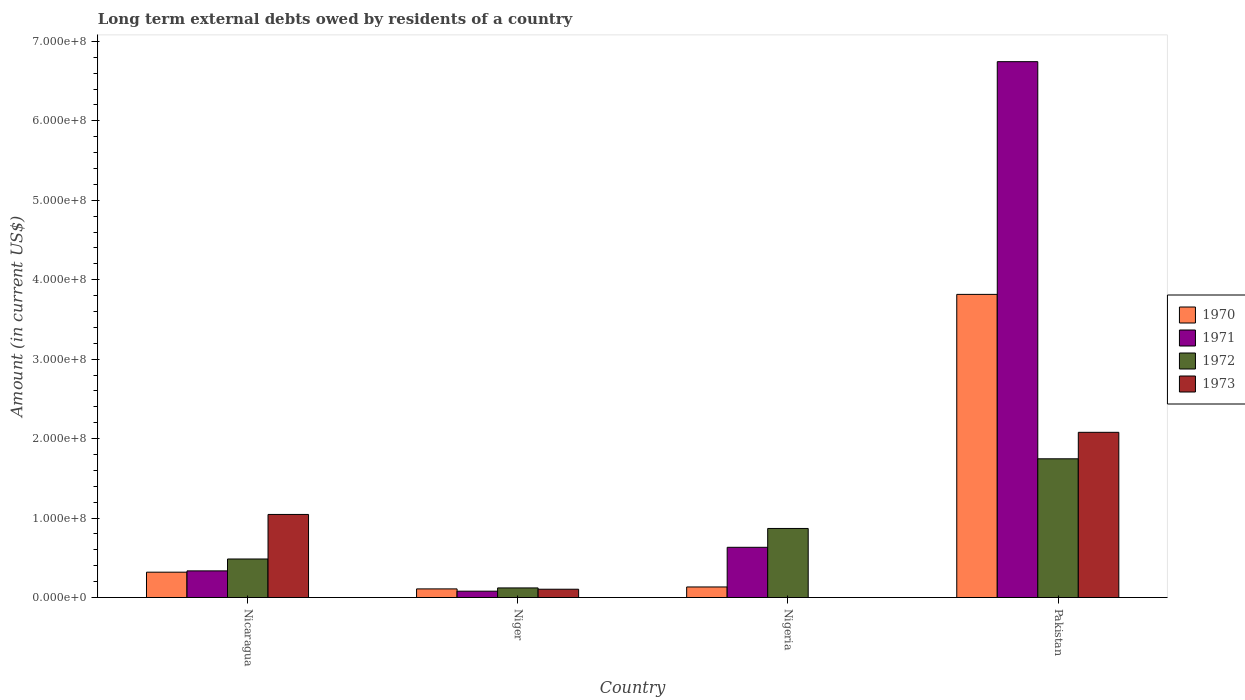How many bars are there on the 3rd tick from the left?
Provide a short and direct response. 3. What is the label of the 3rd group of bars from the left?
Provide a short and direct response. Nigeria. In how many cases, is the number of bars for a given country not equal to the number of legend labels?
Offer a terse response. 1. What is the amount of long-term external debts owed by residents in 1972 in Nigeria?
Make the answer very short. 8.69e+07. Across all countries, what is the maximum amount of long-term external debts owed by residents in 1973?
Your response must be concise. 2.08e+08. Across all countries, what is the minimum amount of long-term external debts owed by residents in 1971?
Make the answer very short. 8.00e+06. What is the total amount of long-term external debts owed by residents in 1970 in the graph?
Your answer should be very brief. 4.38e+08. What is the difference between the amount of long-term external debts owed by residents in 1970 in Nicaragua and that in Niger?
Keep it short and to the point. 2.10e+07. What is the difference between the amount of long-term external debts owed by residents in 1973 in Nicaragua and the amount of long-term external debts owed by residents in 1972 in Nigeria?
Offer a terse response. 1.77e+07. What is the average amount of long-term external debts owed by residents in 1971 per country?
Make the answer very short. 1.95e+08. What is the difference between the amount of long-term external debts owed by residents of/in 1971 and amount of long-term external debts owed by residents of/in 1973 in Pakistan?
Your response must be concise. 4.67e+08. In how many countries, is the amount of long-term external debts owed by residents in 1971 greater than 20000000 US$?
Make the answer very short. 3. What is the ratio of the amount of long-term external debts owed by residents in 1972 in Niger to that in Pakistan?
Make the answer very short. 0.07. Is the difference between the amount of long-term external debts owed by residents in 1971 in Nicaragua and Niger greater than the difference between the amount of long-term external debts owed by residents in 1973 in Nicaragua and Niger?
Your answer should be compact. No. What is the difference between the highest and the second highest amount of long-term external debts owed by residents in 1973?
Make the answer very short. 1.97e+08. What is the difference between the highest and the lowest amount of long-term external debts owed by residents in 1973?
Provide a short and direct response. 2.08e+08. Is the sum of the amount of long-term external debts owed by residents in 1971 in Nigeria and Pakistan greater than the maximum amount of long-term external debts owed by residents in 1970 across all countries?
Your response must be concise. Yes. Is it the case that in every country, the sum of the amount of long-term external debts owed by residents in 1971 and amount of long-term external debts owed by residents in 1973 is greater than the sum of amount of long-term external debts owed by residents in 1970 and amount of long-term external debts owed by residents in 1972?
Provide a succinct answer. No. Are all the bars in the graph horizontal?
Offer a very short reply. No. How many countries are there in the graph?
Offer a very short reply. 4. Are the values on the major ticks of Y-axis written in scientific E-notation?
Offer a terse response. Yes. Does the graph contain grids?
Ensure brevity in your answer.  No. Where does the legend appear in the graph?
Your answer should be compact. Center right. How many legend labels are there?
Your response must be concise. 4. What is the title of the graph?
Your answer should be compact. Long term external debts owed by residents of a country. Does "1987" appear as one of the legend labels in the graph?
Your response must be concise. No. What is the label or title of the X-axis?
Your answer should be very brief. Country. What is the label or title of the Y-axis?
Ensure brevity in your answer.  Amount (in current US$). What is the Amount (in current US$) in 1970 in Nicaragua?
Offer a terse response. 3.19e+07. What is the Amount (in current US$) of 1971 in Nicaragua?
Make the answer very short. 3.35e+07. What is the Amount (in current US$) of 1972 in Nicaragua?
Your response must be concise. 4.85e+07. What is the Amount (in current US$) of 1973 in Nicaragua?
Provide a succinct answer. 1.05e+08. What is the Amount (in current US$) of 1970 in Niger?
Offer a terse response. 1.09e+07. What is the Amount (in current US$) of 1971 in Niger?
Keep it short and to the point. 8.00e+06. What is the Amount (in current US$) in 1972 in Niger?
Make the answer very short. 1.21e+07. What is the Amount (in current US$) in 1973 in Niger?
Provide a short and direct response. 1.04e+07. What is the Amount (in current US$) in 1970 in Nigeria?
Provide a short and direct response. 1.33e+07. What is the Amount (in current US$) in 1971 in Nigeria?
Make the answer very short. 6.32e+07. What is the Amount (in current US$) of 1972 in Nigeria?
Keep it short and to the point. 8.69e+07. What is the Amount (in current US$) in 1973 in Nigeria?
Give a very brief answer. 0. What is the Amount (in current US$) of 1970 in Pakistan?
Make the answer very short. 3.82e+08. What is the Amount (in current US$) in 1971 in Pakistan?
Make the answer very short. 6.74e+08. What is the Amount (in current US$) in 1972 in Pakistan?
Your answer should be very brief. 1.75e+08. What is the Amount (in current US$) in 1973 in Pakistan?
Your response must be concise. 2.08e+08. Across all countries, what is the maximum Amount (in current US$) of 1970?
Your answer should be compact. 3.82e+08. Across all countries, what is the maximum Amount (in current US$) in 1971?
Provide a short and direct response. 6.74e+08. Across all countries, what is the maximum Amount (in current US$) of 1972?
Your answer should be compact. 1.75e+08. Across all countries, what is the maximum Amount (in current US$) in 1973?
Your answer should be very brief. 2.08e+08. Across all countries, what is the minimum Amount (in current US$) in 1970?
Provide a short and direct response. 1.09e+07. Across all countries, what is the minimum Amount (in current US$) in 1971?
Offer a very short reply. 8.00e+06. Across all countries, what is the minimum Amount (in current US$) in 1972?
Make the answer very short. 1.21e+07. Across all countries, what is the minimum Amount (in current US$) in 1973?
Keep it short and to the point. 0. What is the total Amount (in current US$) of 1970 in the graph?
Offer a terse response. 4.38e+08. What is the total Amount (in current US$) in 1971 in the graph?
Ensure brevity in your answer.  7.79e+08. What is the total Amount (in current US$) of 1972 in the graph?
Offer a terse response. 3.22e+08. What is the total Amount (in current US$) in 1973 in the graph?
Your answer should be compact. 3.23e+08. What is the difference between the Amount (in current US$) of 1970 in Nicaragua and that in Niger?
Ensure brevity in your answer.  2.10e+07. What is the difference between the Amount (in current US$) of 1971 in Nicaragua and that in Niger?
Offer a terse response. 2.55e+07. What is the difference between the Amount (in current US$) of 1972 in Nicaragua and that in Niger?
Ensure brevity in your answer.  3.64e+07. What is the difference between the Amount (in current US$) of 1973 in Nicaragua and that in Niger?
Make the answer very short. 9.41e+07. What is the difference between the Amount (in current US$) in 1970 in Nicaragua and that in Nigeria?
Make the answer very short. 1.86e+07. What is the difference between the Amount (in current US$) in 1971 in Nicaragua and that in Nigeria?
Provide a succinct answer. -2.97e+07. What is the difference between the Amount (in current US$) of 1972 in Nicaragua and that in Nigeria?
Make the answer very short. -3.84e+07. What is the difference between the Amount (in current US$) of 1970 in Nicaragua and that in Pakistan?
Your answer should be compact. -3.50e+08. What is the difference between the Amount (in current US$) in 1971 in Nicaragua and that in Pakistan?
Your response must be concise. -6.41e+08. What is the difference between the Amount (in current US$) of 1972 in Nicaragua and that in Pakistan?
Give a very brief answer. -1.26e+08. What is the difference between the Amount (in current US$) of 1973 in Nicaragua and that in Pakistan?
Offer a terse response. -1.03e+08. What is the difference between the Amount (in current US$) in 1970 in Niger and that in Nigeria?
Your response must be concise. -2.44e+06. What is the difference between the Amount (in current US$) in 1971 in Niger and that in Nigeria?
Offer a terse response. -5.52e+07. What is the difference between the Amount (in current US$) of 1972 in Niger and that in Nigeria?
Ensure brevity in your answer.  -7.48e+07. What is the difference between the Amount (in current US$) of 1970 in Niger and that in Pakistan?
Offer a very short reply. -3.71e+08. What is the difference between the Amount (in current US$) of 1971 in Niger and that in Pakistan?
Offer a very short reply. -6.66e+08. What is the difference between the Amount (in current US$) of 1972 in Niger and that in Pakistan?
Keep it short and to the point. -1.63e+08. What is the difference between the Amount (in current US$) in 1973 in Niger and that in Pakistan?
Offer a very short reply. -1.97e+08. What is the difference between the Amount (in current US$) of 1970 in Nigeria and that in Pakistan?
Offer a terse response. -3.68e+08. What is the difference between the Amount (in current US$) in 1971 in Nigeria and that in Pakistan?
Offer a very short reply. -6.11e+08. What is the difference between the Amount (in current US$) of 1972 in Nigeria and that in Pakistan?
Provide a succinct answer. -8.77e+07. What is the difference between the Amount (in current US$) of 1970 in Nicaragua and the Amount (in current US$) of 1971 in Niger?
Ensure brevity in your answer.  2.39e+07. What is the difference between the Amount (in current US$) in 1970 in Nicaragua and the Amount (in current US$) in 1972 in Niger?
Keep it short and to the point. 1.98e+07. What is the difference between the Amount (in current US$) in 1970 in Nicaragua and the Amount (in current US$) in 1973 in Niger?
Ensure brevity in your answer.  2.15e+07. What is the difference between the Amount (in current US$) in 1971 in Nicaragua and the Amount (in current US$) in 1972 in Niger?
Your response must be concise. 2.14e+07. What is the difference between the Amount (in current US$) in 1971 in Nicaragua and the Amount (in current US$) in 1973 in Niger?
Keep it short and to the point. 2.31e+07. What is the difference between the Amount (in current US$) in 1972 in Nicaragua and the Amount (in current US$) in 1973 in Niger?
Your answer should be very brief. 3.81e+07. What is the difference between the Amount (in current US$) in 1970 in Nicaragua and the Amount (in current US$) in 1971 in Nigeria?
Give a very brief answer. -3.13e+07. What is the difference between the Amount (in current US$) of 1970 in Nicaragua and the Amount (in current US$) of 1972 in Nigeria?
Your answer should be very brief. -5.50e+07. What is the difference between the Amount (in current US$) of 1971 in Nicaragua and the Amount (in current US$) of 1972 in Nigeria?
Give a very brief answer. -5.34e+07. What is the difference between the Amount (in current US$) in 1970 in Nicaragua and the Amount (in current US$) in 1971 in Pakistan?
Your response must be concise. -6.43e+08. What is the difference between the Amount (in current US$) in 1970 in Nicaragua and the Amount (in current US$) in 1972 in Pakistan?
Keep it short and to the point. -1.43e+08. What is the difference between the Amount (in current US$) in 1970 in Nicaragua and the Amount (in current US$) in 1973 in Pakistan?
Provide a short and direct response. -1.76e+08. What is the difference between the Amount (in current US$) in 1971 in Nicaragua and the Amount (in current US$) in 1972 in Pakistan?
Provide a short and direct response. -1.41e+08. What is the difference between the Amount (in current US$) in 1971 in Nicaragua and the Amount (in current US$) in 1973 in Pakistan?
Provide a succinct answer. -1.74e+08. What is the difference between the Amount (in current US$) of 1972 in Nicaragua and the Amount (in current US$) of 1973 in Pakistan?
Your response must be concise. -1.59e+08. What is the difference between the Amount (in current US$) in 1970 in Niger and the Amount (in current US$) in 1971 in Nigeria?
Make the answer very short. -5.24e+07. What is the difference between the Amount (in current US$) in 1970 in Niger and the Amount (in current US$) in 1972 in Nigeria?
Offer a very short reply. -7.61e+07. What is the difference between the Amount (in current US$) of 1971 in Niger and the Amount (in current US$) of 1972 in Nigeria?
Offer a very short reply. -7.89e+07. What is the difference between the Amount (in current US$) of 1970 in Niger and the Amount (in current US$) of 1971 in Pakistan?
Your answer should be very brief. -6.64e+08. What is the difference between the Amount (in current US$) in 1970 in Niger and the Amount (in current US$) in 1972 in Pakistan?
Offer a terse response. -1.64e+08. What is the difference between the Amount (in current US$) of 1970 in Niger and the Amount (in current US$) of 1973 in Pakistan?
Keep it short and to the point. -1.97e+08. What is the difference between the Amount (in current US$) in 1971 in Niger and the Amount (in current US$) in 1972 in Pakistan?
Offer a terse response. -1.67e+08. What is the difference between the Amount (in current US$) in 1971 in Niger and the Amount (in current US$) in 1973 in Pakistan?
Your answer should be compact. -2.00e+08. What is the difference between the Amount (in current US$) of 1972 in Niger and the Amount (in current US$) of 1973 in Pakistan?
Make the answer very short. -1.96e+08. What is the difference between the Amount (in current US$) in 1970 in Nigeria and the Amount (in current US$) in 1971 in Pakistan?
Your answer should be compact. -6.61e+08. What is the difference between the Amount (in current US$) in 1970 in Nigeria and the Amount (in current US$) in 1972 in Pakistan?
Give a very brief answer. -1.61e+08. What is the difference between the Amount (in current US$) of 1970 in Nigeria and the Amount (in current US$) of 1973 in Pakistan?
Provide a short and direct response. -1.95e+08. What is the difference between the Amount (in current US$) of 1971 in Nigeria and the Amount (in current US$) of 1972 in Pakistan?
Give a very brief answer. -1.11e+08. What is the difference between the Amount (in current US$) of 1971 in Nigeria and the Amount (in current US$) of 1973 in Pakistan?
Offer a terse response. -1.45e+08. What is the difference between the Amount (in current US$) in 1972 in Nigeria and the Amount (in current US$) in 1973 in Pakistan?
Keep it short and to the point. -1.21e+08. What is the average Amount (in current US$) in 1970 per country?
Ensure brevity in your answer.  1.09e+08. What is the average Amount (in current US$) of 1971 per country?
Provide a succinct answer. 1.95e+08. What is the average Amount (in current US$) in 1972 per country?
Offer a terse response. 8.05e+07. What is the average Amount (in current US$) in 1973 per country?
Your answer should be very brief. 8.07e+07. What is the difference between the Amount (in current US$) of 1970 and Amount (in current US$) of 1971 in Nicaragua?
Offer a terse response. -1.63e+06. What is the difference between the Amount (in current US$) in 1970 and Amount (in current US$) in 1972 in Nicaragua?
Keep it short and to the point. -1.66e+07. What is the difference between the Amount (in current US$) of 1970 and Amount (in current US$) of 1973 in Nicaragua?
Your answer should be very brief. -7.27e+07. What is the difference between the Amount (in current US$) in 1971 and Amount (in current US$) in 1972 in Nicaragua?
Provide a succinct answer. -1.50e+07. What is the difference between the Amount (in current US$) in 1971 and Amount (in current US$) in 1973 in Nicaragua?
Offer a very short reply. -7.10e+07. What is the difference between the Amount (in current US$) in 1972 and Amount (in current US$) in 1973 in Nicaragua?
Provide a short and direct response. -5.61e+07. What is the difference between the Amount (in current US$) of 1970 and Amount (in current US$) of 1971 in Niger?
Keep it short and to the point. 2.86e+06. What is the difference between the Amount (in current US$) in 1970 and Amount (in current US$) in 1972 in Niger?
Give a very brief answer. -1.23e+06. What is the difference between the Amount (in current US$) in 1970 and Amount (in current US$) in 1973 in Niger?
Offer a terse response. 4.08e+05. What is the difference between the Amount (in current US$) of 1971 and Amount (in current US$) of 1972 in Niger?
Offer a very short reply. -4.09e+06. What is the difference between the Amount (in current US$) in 1971 and Amount (in current US$) in 1973 in Niger?
Provide a short and direct response. -2.45e+06. What is the difference between the Amount (in current US$) of 1972 and Amount (in current US$) of 1973 in Niger?
Make the answer very short. 1.64e+06. What is the difference between the Amount (in current US$) in 1970 and Amount (in current US$) in 1971 in Nigeria?
Keep it short and to the point. -4.99e+07. What is the difference between the Amount (in current US$) in 1970 and Amount (in current US$) in 1972 in Nigeria?
Offer a very short reply. -7.36e+07. What is the difference between the Amount (in current US$) in 1971 and Amount (in current US$) in 1972 in Nigeria?
Keep it short and to the point. -2.37e+07. What is the difference between the Amount (in current US$) of 1970 and Amount (in current US$) of 1971 in Pakistan?
Your response must be concise. -2.93e+08. What is the difference between the Amount (in current US$) in 1970 and Amount (in current US$) in 1972 in Pakistan?
Give a very brief answer. 2.07e+08. What is the difference between the Amount (in current US$) of 1970 and Amount (in current US$) of 1973 in Pakistan?
Your answer should be very brief. 1.74e+08. What is the difference between the Amount (in current US$) of 1971 and Amount (in current US$) of 1972 in Pakistan?
Offer a very short reply. 5.00e+08. What is the difference between the Amount (in current US$) in 1971 and Amount (in current US$) in 1973 in Pakistan?
Make the answer very short. 4.67e+08. What is the difference between the Amount (in current US$) in 1972 and Amount (in current US$) in 1973 in Pakistan?
Your answer should be very brief. -3.33e+07. What is the ratio of the Amount (in current US$) in 1970 in Nicaragua to that in Niger?
Offer a terse response. 2.94. What is the ratio of the Amount (in current US$) in 1971 in Nicaragua to that in Niger?
Your answer should be compact. 4.19. What is the ratio of the Amount (in current US$) in 1972 in Nicaragua to that in Niger?
Provide a short and direct response. 4.01. What is the ratio of the Amount (in current US$) in 1973 in Nicaragua to that in Niger?
Your answer should be very brief. 10.01. What is the ratio of the Amount (in current US$) of 1970 in Nicaragua to that in Nigeria?
Make the answer very short. 2.4. What is the ratio of the Amount (in current US$) in 1971 in Nicaragua to that in Nigeria?
Provide a succinct answer. 0.53. What is the ratio of the Amount (in current US$) in 1972 in Nicaragua to that in Nigeria?
Keep it short and to the point. 0.56. What is the ratio of the Amount (in current US$) in 1970 in Nicaragua to that in Pakistan?
Keep it short and to the point. 0.08. What is the ratio of the Amount (in current US$) in 1971 in Nicaragua to that in Pakistan?
Provide a short and direct response. 0.05. What is the ratio of the Amount (in current US$) in 1972 in Nicaragua to that in Pakistan?
Keep it short and to the point. 0.28. What is the ratio of the Amount (in current US$) of 1973 in Nicaragua to that in Pakistan?
Your answer should be very brief. 0.5. What is the ratio of the Amount (in current US$) in 1970 in Niger to that in Nigeria?
Make the answer very short. 0.82. What is the ratio of the Amount (in current US$) in 1971 in Niger to that in Nigeria?
Give a very brief answer. 0.13. What is the ratio of the Amount (in current US$) of 1972 in Niger to that in Nigeria?
Provide a short and direct response. 0.14. What is the ratio of the Amount (in current US$) of 1970 in Niger to that in Pakistan?
Ensure brevity in your answer.  0.03. What is the ratio of the Amount (in current US$) of 1971 in Niger to that in Pakistan?
Your answer should be very brief. 0.01. What is the ratio of the Amount (in current US$) of 1972 in Niger to that in Pakistan?
Keep it short and to the point. 0.07. What is the ratio of the Amount (in current US$) in 1973 in Niger to that in Pakistan?
Your answer should be compact. 0.05. What is the ratio of the Amount (in current US$) of 1970 in Nigeria to that in Pakistan?
Ensure brevity in your answer.  0.03. What is the ratio of the Amount (in current US$) of 1971 in Nigeria to that in Pakistan?
Your answer should be compact. 0.09. What is the ratio of the Amount (in current US$) in 1972 in Nigeria to that in Pakistan?
Your answer should be compact. 0.5. What is the difference between the highest and the second highest Amount (in current US$) of 1970?
Ensure brevity in your answer.  3.50e+08. What is the difference between the highest and the second highest Amount (in current US$) of 1971?
Provide a succinct answer. 6.11e+08. What is the difference between the highest and the second highest Amount (in current US$) of 1972?
Make the answer very short. 8.77e+07. What is the difference between the highest and the second highest Amount (in current US$) of 1973?
Make the answer very short. 1.03e+08. What is the difference between the highest and the lowest Amount (in current US$) in 1970?
Your answer should be very brief. 3.71e+08. What is the difference between the highest and the lowest Amount (in current US$) in 1971?
Ensure brevity in your answer.  6.66e+08. What is the difference between the highest and the lowest Amount (in current US$) in 1972?
Provide a short and direct response. 1.63e+08. What is the difference between the highest and the lowest Amount (in current US$) in 1973?
Your answer should be compact. 2.08e+08. 